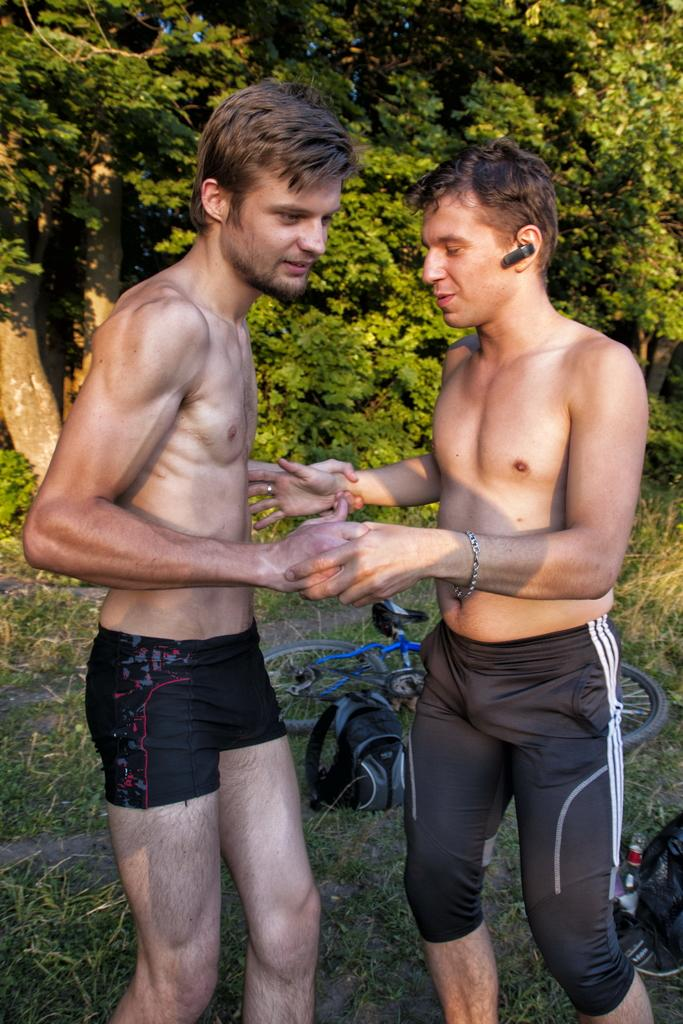How many people are in the image? There are two men standing in the image. What can be seen in the background of the image? There are trees in the background of the image. What type of vegetation is visible at the bottom of the image? Grass is visible at the bottom of the image. How many patches are on the door in the image? There is no door present in the image, so it is not possible to determine the number of patches on a door. 